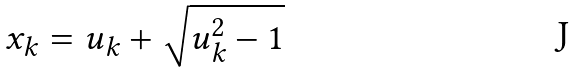<formula> <loc_0><loc_0><loc_500><loc_500>x _ { k } = u _ { k } + \sqrt { u _ { k } ^ { 2 } - 1 }</formula> 